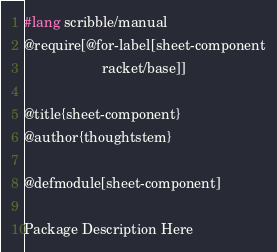Convert code to text. <code><loc_0><loc_0><loc_500><loc_500><_Racket_>#lang scribble/manual
@require[@for-label[sheet-component
                    racket/base]]

@title{sheet-component}
@author{thoughtstem}

@defmodule[sheet-component]

Package Description Here
</code> 